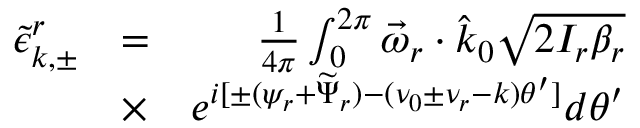Convert formula to latex. <formula><loc_0><loc_0><loc_500><loc_500>\begin{array} { r l r } { \tilde { \epsilon } _ { k , \pm } ^ { r } } & { = } & { \frac { 1 } { 4 \pi } \int _ { 0 } ^ { 2 \pi } \vec { \omega } _ { r } \cdot \hat { k } _ { 0 } \sqrt { 2 I _ { r } \beta _ { r } } } \\ & { \times } & { e ^ { i [ \pm ( \psi _ { r } + \widetilde { \Psi } _ { r } ) - ( \nu _ { 0 } \pm \nu _ { r } - k ) \theta ^ { \prime } ] } d \theta ^ { \prime } } \end{array}</formula> 